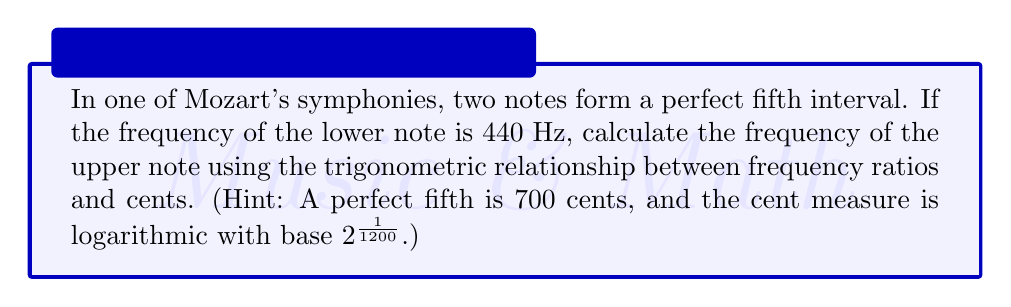Can you solve this math problem? Let's approach this step-by-step:

1) First, recall the relationship between cents and frequency ratio:
   $$n = 1200 \log_2(\frac{f_2}{f_1})$$
   where $n$ is the number of cents, $f_2$ is the higher frequency, and $f_1$ is the lower frequency.

2) We know that a perfect fifth is 700 cents, so $n = 700$. We also know $f_1 = 440$ Hz. Let's substitute these into our equation:
   $$700 = 1200 \log_2(\frac{f_2}{440})$$

3) Now, let's solve for $f_2$:
   $$\frac{700}{1200} = \log_2(\frac{f_2}{440})$$

4) This can be rewritten as:
   $$2^{\frac{700}{1200}} = \frac{f_2}{440}$$

5) Multiply both sides by 440:
   $$440 \cdot 2^{\frac{700}{1200}} = f_2$$

6) Now we can calculate this:
   $$f_2 = 440 \cdot 2^{\frac{7}{12}} \approx 659.26 \text{ Hz}$$

7) This result can be verified using the fact that a perfect fifth has a frequency ratio of 3:2:
   $$440 \cdot \frac{3}{2} = 660 \text{ Hz}$$
   The small difference is due to rounding in the cent system.
Answer: $659.26 \text{ Hz}$ 